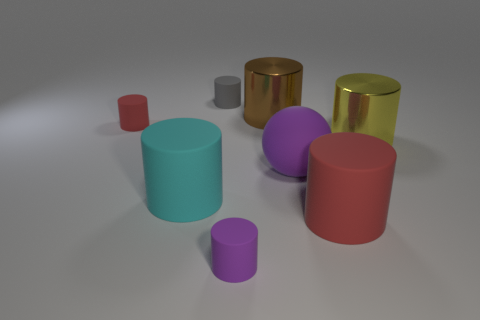Subtract all red cylinders. How many cylinders are left? 5 Subtract all large matte cylinders. How many cylinders are left? 5 Subtract all green cylinders. Subtract all brown blocks. How many cylinders are left? 7 Add 2 cyan matte objects. How many objects exist? 10 Subtract all spheres. How many objects are left? 7 Add 4 small gray cylinders. How many small gray cylinders exist? 5 Subtract 1 red cylinders. How many objects are left? 7 Subtract all yellow blocks. Subtract all red cylinders. How many objects are left? 6 Add 3 brown cylinders. How many brown cylinders are left? 4 